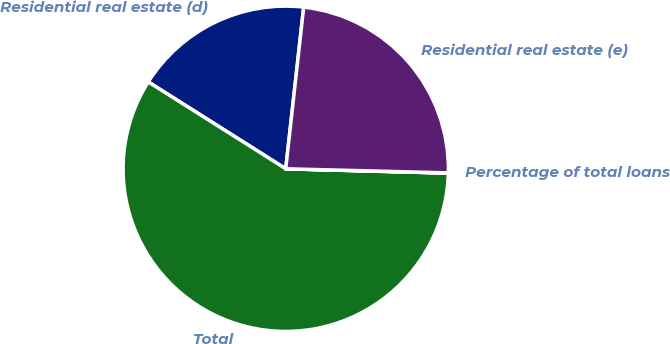<chart> <loc_0><loc_0><loc_500><loc_500><pie_chart><fcel>Residential real estate (d)<fcel>Total<fcel>Percentage of total loans<fcel>Residential real estate (e)<nl><fcel>17.79%<fcel>58.54%<fcel>0.03%<fcel>23.64%<nl></chart> 